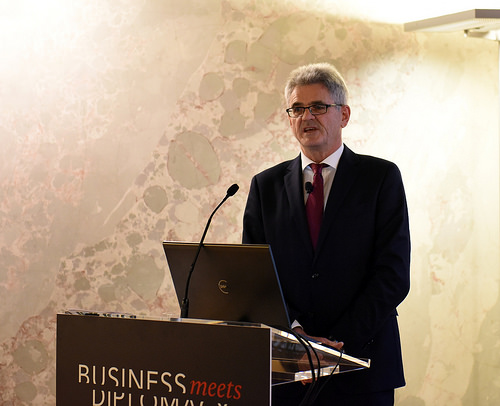<image>
Is the laptop behind the podium? Yes. From this viewpoint, the laptop is positioned behind the podium, with the podium partially or fully occluding the laptop. 